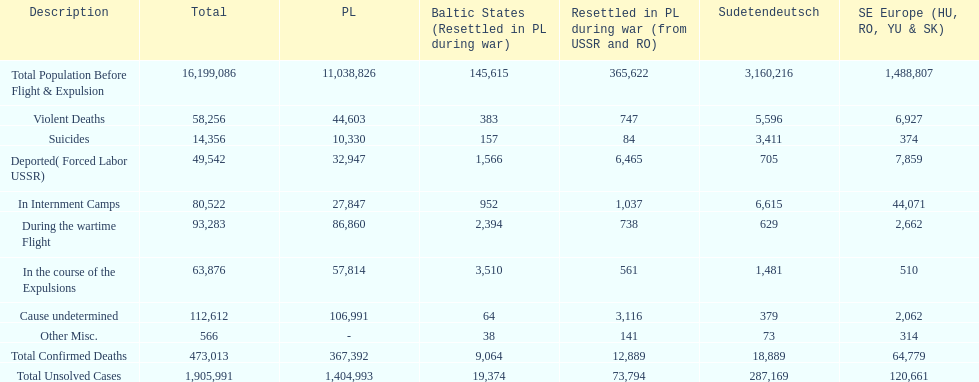Which region had the least total of unsolved cases? Baltic States(Resettled in Poland during war). Would you mind parsing the complete table? {'header': ['Description', 'Total', 'PL', 'Baltic States (Resettled in PL during war)', 'Resettled in PL during war (from USSR and RO)', 'Sudetendeutsch', 'SE Europe (HU, RO, YU & SK)'], 'rows': [['Total Population Before Flight & Expulsion', '16,199,086', '11,038,826', '145,615', '365,622', '3,160,216', '1,488,807'], ['Violent Deaths', '58,256', '44,603', '383', '747', '5,596', '6,927'], ['Suicides', '14,356', '10,330', '157', '84', '3,411', '374'], ['Deported( Forced Labor USSR)', '49,542', '32,947', '1,566', '6,465', '705', '7,859'], ['In Internment Camps', '80,522', '27,847', '952', '1,037', '6,615', '44,071'], ['During the wartime Flight', '93,283', '86,860', '2,394', '738', '629', '2,662'], ['In the course of the Expulsions', '63,876', '57,814', '3,510', '561', '1,481', '510'], ['Cause undetermined', '112,612', '106,991', '64', '3,116', '379', '2,062'], ['Other Misc.', '566', '-', '38', '141', '73', '314'], ['Total Confirmed Deaths', '473,013', '367,392', '9,064', '12,889', '18,889', '64,779'], ['Total Unsolved Cases', '1,905,991', '1,404,993', '19,374', '73,794', '287,169', '120,661']]} 